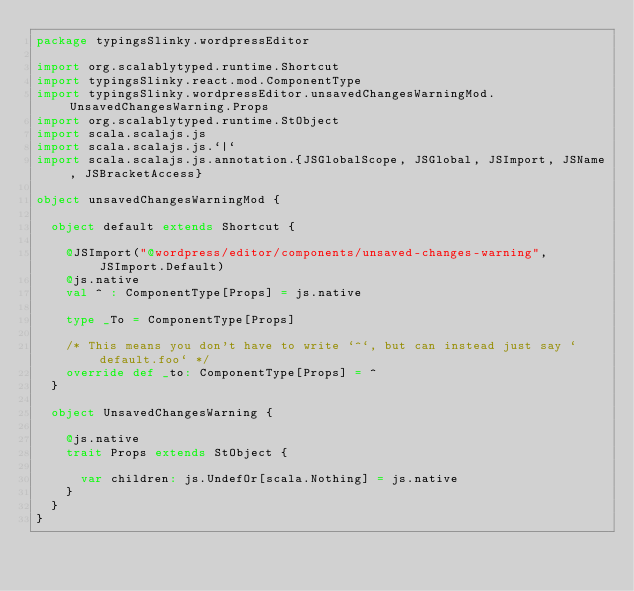Convert code to text. <code><loc_0><loc_0><loc_500><loc_500><_Scala_>package typingsSlinky.wordpressEditor

import org.scalablytyped.runtime.Shortcut
import typingsSlinky.react.mod.ComponentType
import typingsSlinky.wordpressEditor.unsavedChangesWarningMod.UnsavedChangesWarning.Props
import org.scalablytyped.runtime.StObject
import scala.scalajs.js
import scala.scalajs.js.`|`
import scala.scalajs.js.annotation.{JSGlobalScope, JSGlobal, JSImport, JSName, JSBracketAccess}

object unsavedChangesWarningMod {
  
  object default extends Shortcut {
    
    @JSImport("@wordpress/editor/components/unsaved-changes-warning", JSImport.Default)
    @js.native
    val ^ : ComponentType[Props] = js.native
    
    type _To = ComponentType[Props]
    
    /* This means you don't have to write `^`, but can instead just say `default.foo` */
    override def _to: ComponentType[Props] = ^
  }
  
  object UnsavedChangesWarning {
    
    @js.native
    trait Props extends StObject {
      
      var children: js.UndefOr[scala.Nothing] = js.native
    }
  }
}
</code> 